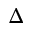<formula> <loc_0><loc_0><loc_500><loc_500>\Delta</formula> 